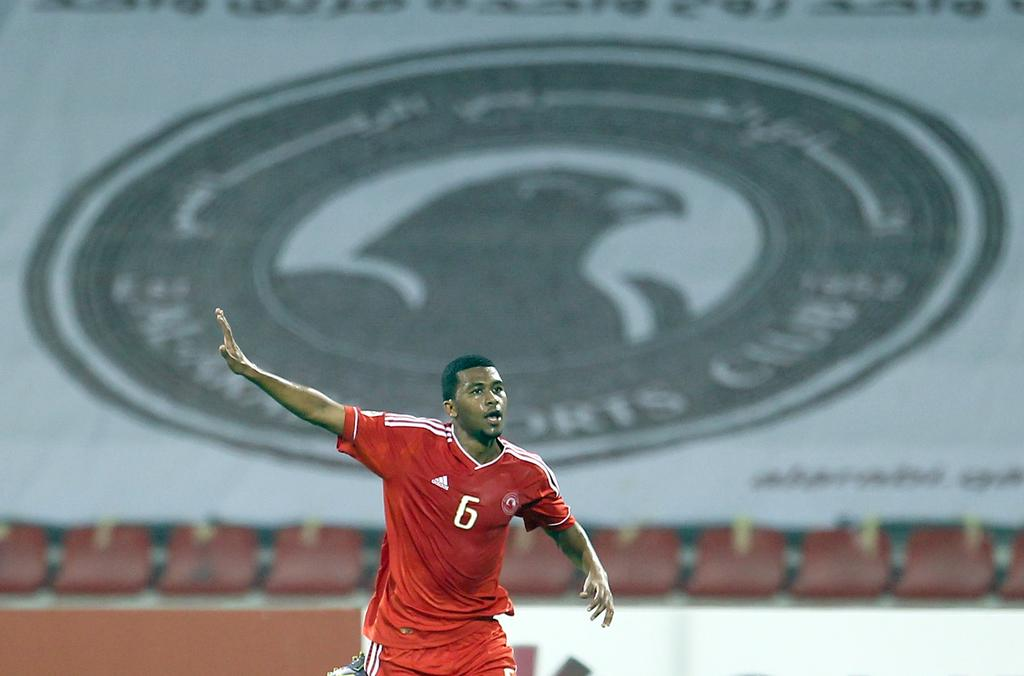<image>
Give a short and clear explanation of the subsequent image. A soccer player wearing number 6 posing on a field. 